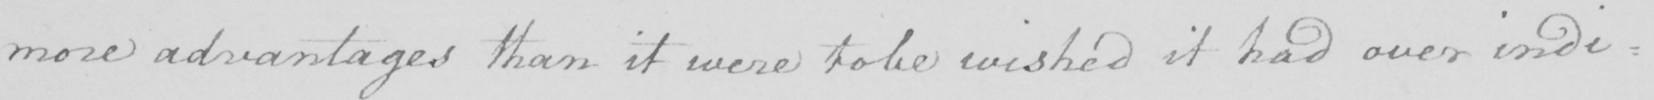Please provide the text content of this handwritten line. more advantages than it were to be wished it had over indi : 